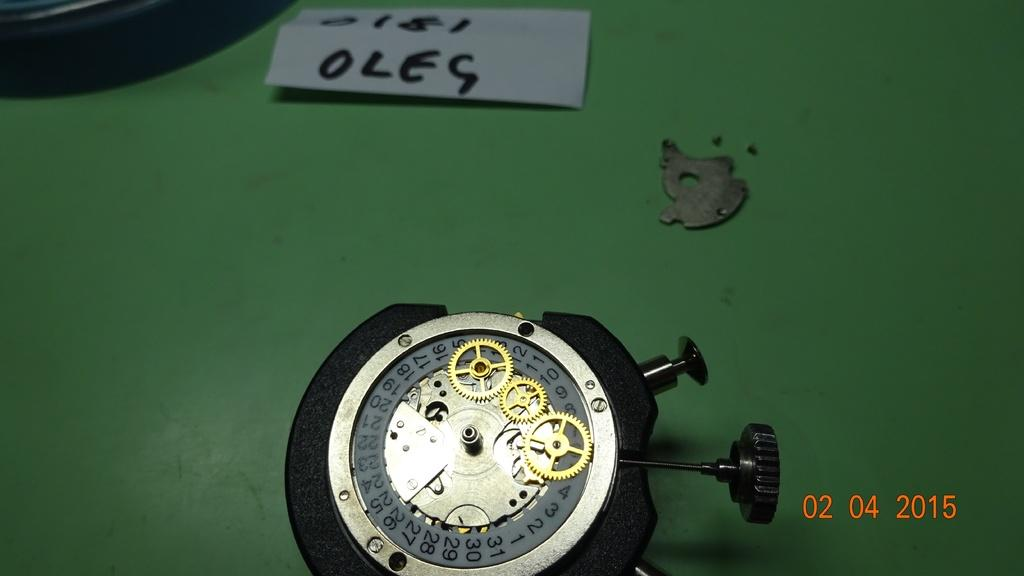<image>
Describe the image concisely. A timer and piece of paper that reads OLEG. 